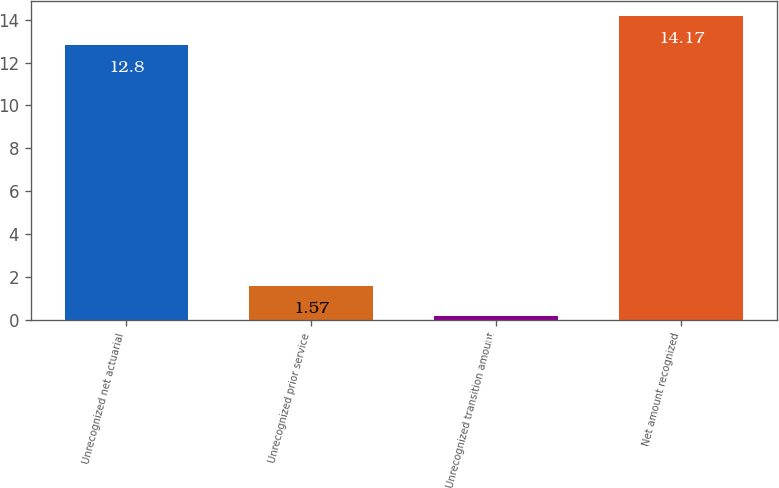<chart> <loc_0><loc_0><loc_500><loc_500><bar_chart><fcel>Unrecognized net actuarial<fcel>Unrecognized prior service<fcel>Unrecognized transition amount<fcel>Net amount recognized<nl><fcel>12.8<fcel>1.57<fcel>0.2<fcel>14.17<nl></chart> 